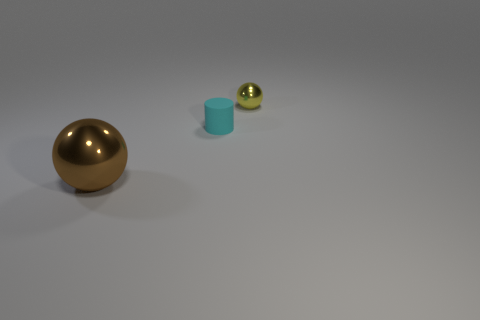There is a sphere right of the shiny thing that is in front of the sphere that is to the right of the brown object; what color is it?
Offer a very short reply. Yellow. Are there any other large brown shiny objects that have the same shape as the brown metal object?
Offer a very short reply. No. What number of large purple metallic cubes are there?
Keep it short and to the point. 0. What is the shape of the brown metal thing?
Ensure brevity in your answer.  Sphere. What number of metal objects have the same size as the matte object?
Your answer should be compact. 1. Do the small yellow shiny thing and the cyan matte thing have the same shape?
Provide a short and direct response. No. What color is the rubber cylinder behind the ball that is left of the small cyan rubber thing?
Your answer should be very brief. Cyan. What size is the object that is both to the left of the yellow thing and behind the large brown object?
Your answer should be very brief. Small. Are there any other things that are the same color as the small matte cylinder?
Your answer should be compact. No. What shape is the large object that is made of the same material as the tiny yellow sphere?
Offer a terse response. Sphere. 